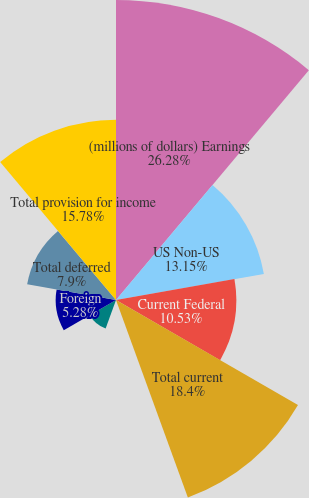Convert chart to OTSL. <chart><loc_0><loc_0><loc_500><loc_500><pie_chart><fcel>(millions of dollars) Earnings<fcel>US Non-US<fcel>Current Federal<fcel>Total current<fcel>Federal<fcel>State<fcel>Foreign<fcel>Total deferred<fcel>Total provision for income<nl><fcel>26.27%<fcel>13.15%<fcel>10.53%<fcel>18.4%<fcel>0.03%<fcel>2.65%<fcel>5.28%<fcel>7.9%<fcel>15.78%<nl></chart> 